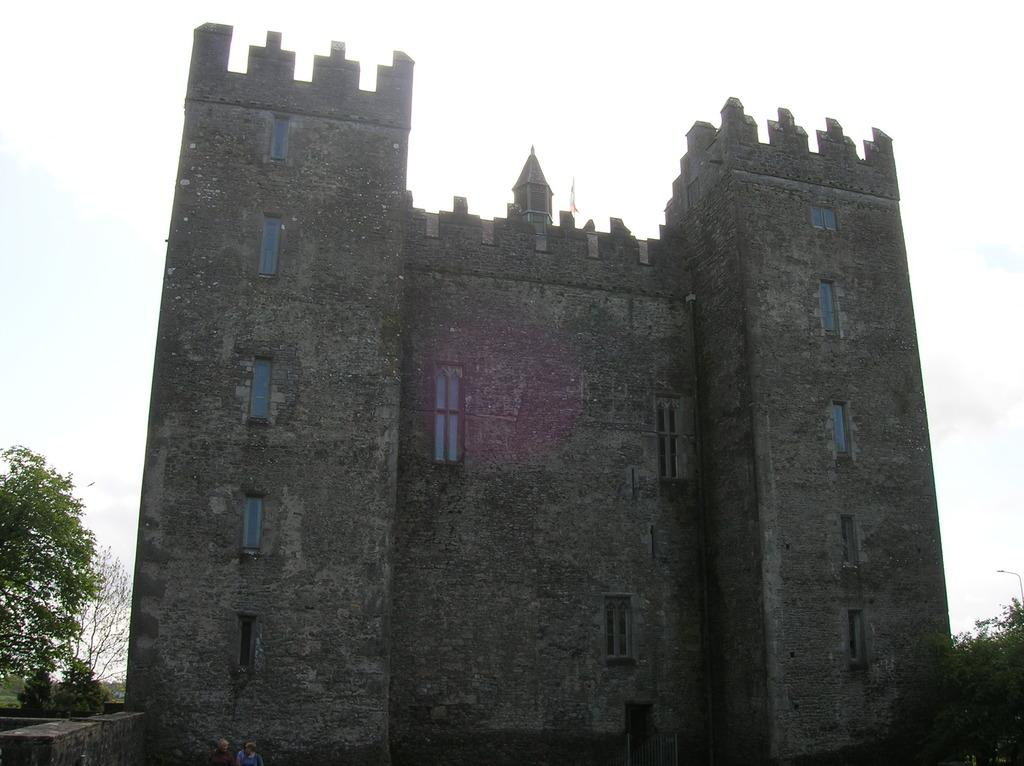What type of structure is in the image? There is a castle in the image. What feature of the castle is mentioned in the facts? The castle has many windows. Where is the castle located? The castle is on land. What can be seen on either side of the castle? There are plants on either side of the castle. What is visible above the castle? The sky is visible above the castle. How many pairs of underwear can be seen hanging from the castle walls in the image? There are no underwear visible in the image; it features a castle with plants and a sky. 